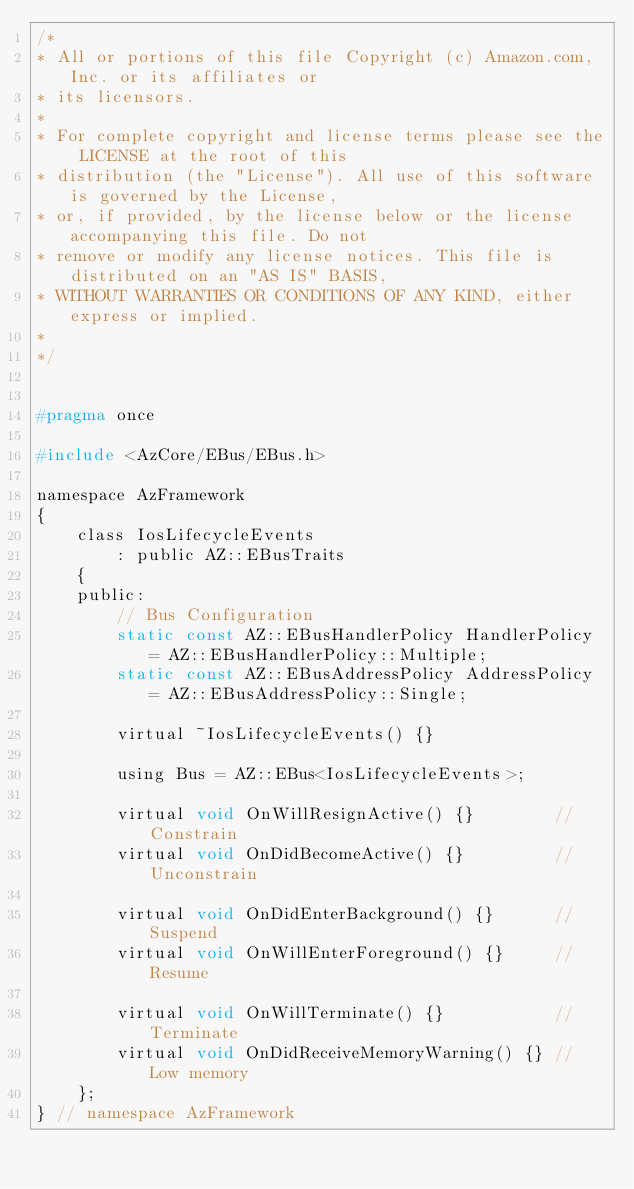<code> <loc_0><loc_0><loc_500><loc_500><_C_>/*
* All or portions of this file Copyright (c) Amazon.com, Inc. or its affiliates or
* its licensors.
*
* For complete copyright and license terms please see the LICENSE at the root of this
* distribution (the "License"). All use of this software is governed by the License,
* or, if provided, by the license below or the license accompanying this file. Do not
* remove or modify any license notices. This file is distributed on an "AS IS" BASIS,
* WITHOUT WARRANTIES OR CONDITIONS OF ANY KIND, either express or implied.
*
*/


#pragma once

#include <AzCore/EBus/EBus.h>

namespace AzFramework
{
    class IosLifecycleEvents
        : public AZ::EBusTraits
    {
    public:
        // Bus Configuration
        static const AZ::EBusHandlerPolicy HandlerPolicy = AZ::EBusHandlerPolicy::Multiple;
        static const AZ::EBusAddressPolicy AddressPolicy = AZ::EBusAddressPolicy::Single;

        virtual ~IosLifecycleEvents() {}

        using Bus = AZ::EBus<IosLifecycleEvents>;

        virtual void OnWillResignActive() {}        // Constrain
        virtual void OnDidBecomeActive() {}         // Unconstrain

        virtual void OnDidEnterBackground() {}      // Suspend
        virtual void OnWillEnterForeground() {}     // Resume

        virtual void OnWillTerminate() {}           // Terminate
        virtual void OnDidReceiveMemoryWarning() {} // Low memory
    };
} // namespace AzFramework
</code> 